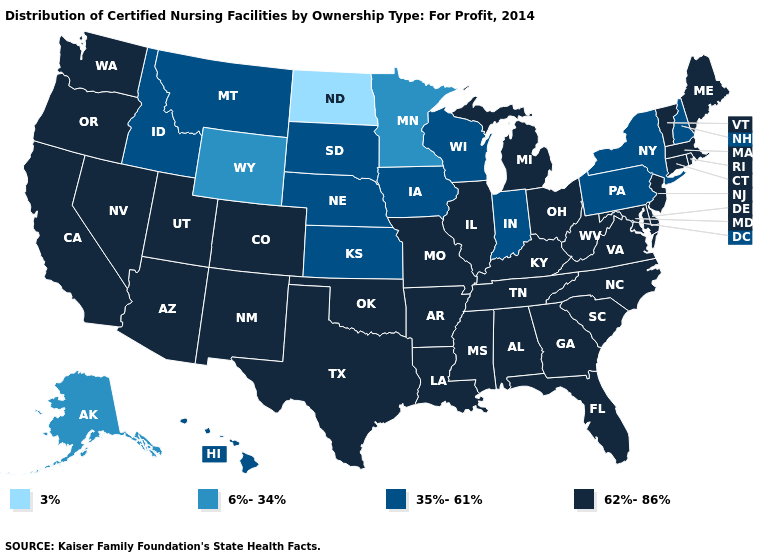Among the states that border New Mexico , which have the highest value?
Keep it brief. Arizona, Colorado, Oklahoma, Texas, Utah. What is the lowest value in the USA?
Answer briefly. 3%. What is the value of Alaska?
Be succinct. 6%-34%. What is the value of Arizona?
Concise answer only. 62%-86%. What is the value of Oklahoma?
Keep it brief. 62%-86%. Which states have the lowest value in the USA?
Be succinct. North Dakota. Does Colorado have a lower value than Wisconsin?
Write a very short answer. No. What is the value of Idaho?
Give a very brief answer. 35%-61%. Does Illinois have the highest value in the MidWest?
Quick response, please. Yes. What is the lowest value in states that border Tennessee?
Answer briefly. 62%-86%. Name the states that have a value in the range 3%?
Keep it brief. North Dakota. Name the states that have a value in the range 3%?
Give a very brief answer. North Dakota. Which states hav the highest value in the MidWest?
Be succinct. Illinois, Michigan, Missouri, Ohio. Which states have the highest value in the USA?
Be succinct. Alabama, Arizona, Arkansas, California, Colorado, Connecticut, Delaware, Florida, Georgia, Illinois, Kentucky, Louisiana, Maine, Maryland, Massachusetts, Michigan, Mississippi, Missouri, Nevada, New Jersey, New Mexico, North Carolina, Ohio, Oklahoma, Oregon, Rhode Island, South Carolina, Tennessee, Texas, Utah, Vermont, Virginia, Washington, West Virginia. 